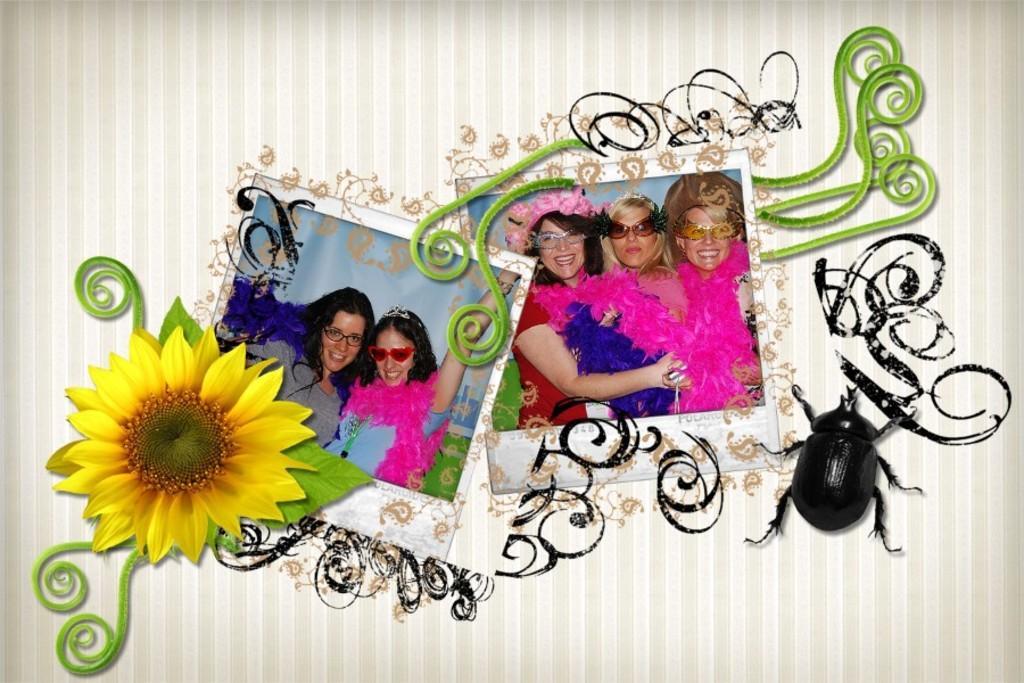How would you summarize this image in a sentence or two? This is an edited picture. In the center of the picture there are two photographs, in the photographs there are women. On the right there is an insect. On the left there is a sunflower. In this picture there is some design. 